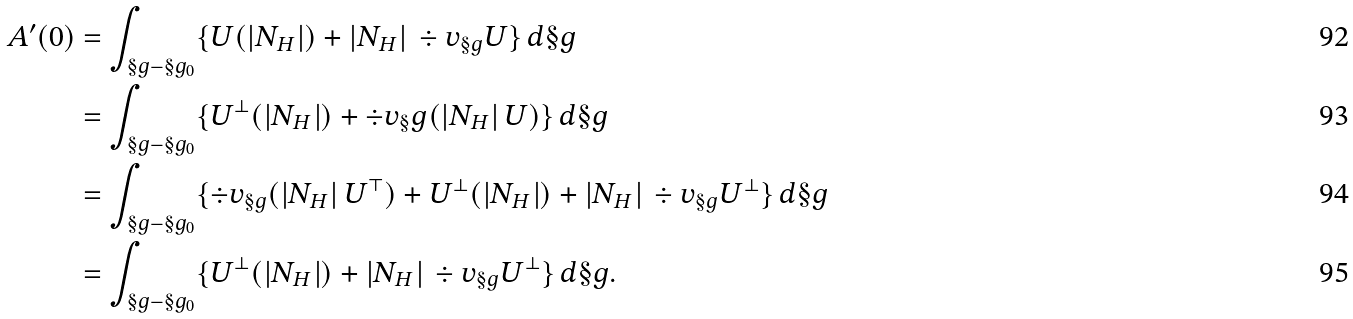<formula> <loc_0><loc_0><loc_500><loc_500>A ^ { \prime } ( 0 ) & = \int _ { \S g - \S g _ { 0 } } \{ U ( | N _ { H } | ) + | N _ { H } | \, \div v _ { \S g } U \} \, d \S g \\ & = \int _ { \S g - \S g _ { 0 } } \{ U ^ { \bot } ( | N _ { H } | ) + \div v _ { \S } g ( | N _ { H } | \, U ) \} \, d \S g \\ & = \int _ { \S g - \S g _ { 0 } } \{ \div v _ { \S g } ( | N _ { H } | \, U ^ { \top } ) + U ^ { \bot } ( | N _ { H } | ) + | N _ { H } | \, \div v _ { \S g } U ^ { \bot } \} \, d \S g \\ & = \int _ { \S g - \S g _ { 0 } } \{ U ^ { \bot } ( | N _ { H } | ) + | N _ { H } | \, \div v _ { \S g } U ^ { \bot } \} \, d \S g .</formula> 